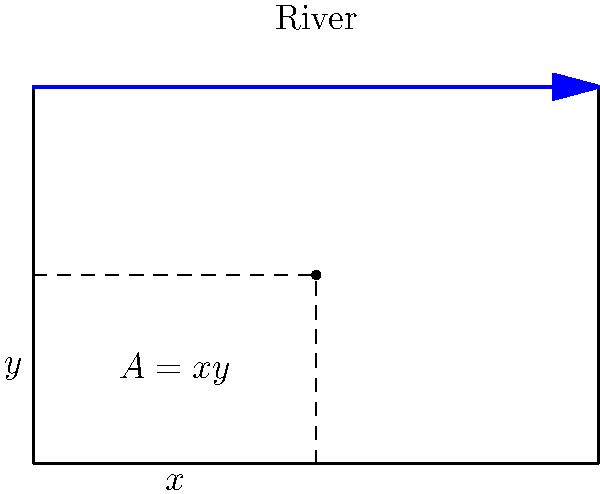A farmer wants to fence off a rectangular field adjacent to a straight river. If the farmer has 1000 feet of fencing available, what are the dimensions of the field that will maximize its area? Assume the river acts as one side of the rectangle and doesn't need fencing. Let's approach this step-by-step:

1) Let $x$ be the width and $y$ be the length of the field.

2) The area of the field is given by $A = xy$.

3) Since the river acts as one side, we only need to fence three sides. So, our constraint equation is:
   $2x + y = 1000$ (fencing constraint)

4) We can express $y$ in terms of $x$:
   $y = 1000 - 2x$

5) Now, we can write the area as a function of $x$:
   $A(x) = x(1000 - 2x) = 1000x - 2x^2$

6) To find the maximum, we differentiate $A(x)$ and set it to zero:
   $\frac{dA}{dx} = 1000 - 4x = 0$

7) Solving this:
   $1000 - 4x = 0$
   $4x = 1000$
   $x = 250$

8) We can find $y$ by substituting this value of $x$ back into our constraint equation:
   $y = 1000 - 2(250) = 500$

9) To confirm this is a maximum, we can check the second derivative:
   $\frac{d^2A}{dx^2} = -4$, which is negative, confirming a maximum.

Therefore, the dimensions that maximize the area are 250 feet for the width and 500 feet for the length.
Answer: Width: 250 feet, Length: 500 feet 